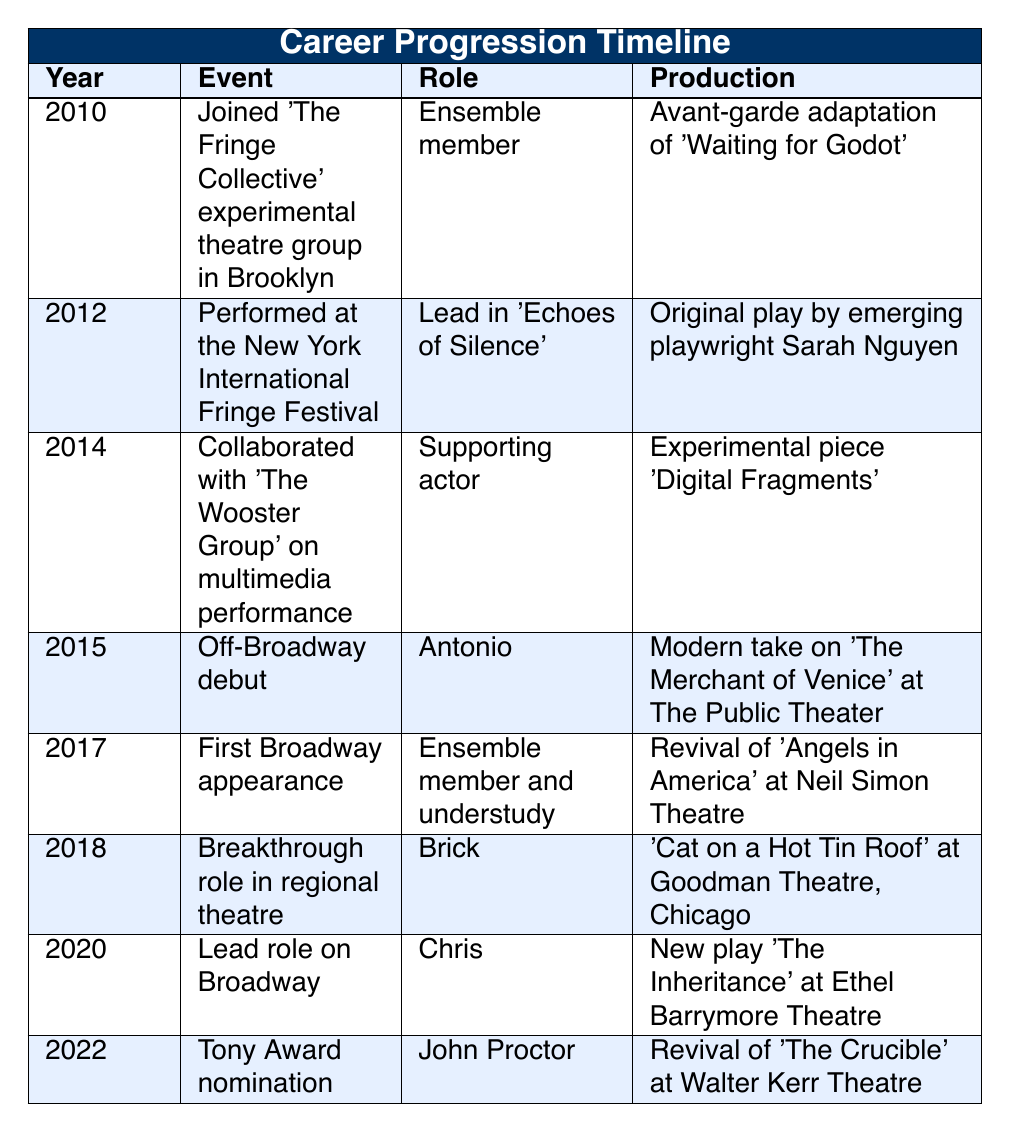What year did the actor join 'The Fringe Collective'? According to the table, the actor joined 'The Fringe Collective' in the year 2010.
Answer: 2010 What was the role played in the 2015 Off-Broadway debut? In the 2015 Off-Broadway debut, the actor played the role of Antonio in a modern adaptation of 'The Merchant of Venice' at The Public Theater.
Answer: Antonio How many years passed between the actor's first Broadway appearance and their Tony Award nomination? The first Broadway appearance took place in 2017, and the Tony Award nomination was in 2022. Therefore, the difference is 2022 - 2017 = 5 years.
Answer: 5 years Is the role of Chris in 'The Inheritance' a lead role or a supporting role? The table classifies Chris in 'The Inheritance' as a lead role on Broadway, which clearly indicates it is not a supporting role.
Answer: Yes In which year did the actor experience a breakthrough role in regional theatre? The table specifies the breakthrough role in regional theatre occurred in 2018 when the actor played Brick in 'Cat on a Hot Tin Roof' at Goodman Theatre, Chicago.
Answer: 2018 What productions did the actor participate in during 2014 and 2015? In 2014, the actor collaborated with 'The Wooster Group' on 'Digital Fragments' as a supporting actor. In 2015, they had their Off-Broadway debut in 'The Merchant of Venice' as Antonio.
Answer: 'Digital Fragments' and 'The Merchant of Venice' Which event was performed at the New York International Fringe Festival? The event at the New York International Fringe Festival was 'Echoes of Silence,' where the actor played the lead role in 2012.
Answer: 'Echoes of Silence' How does the number of years between joining the experimental theatre and the breakthrough role compare to the time from breakthrough role to a lead role on Broadway? The actor joined the experimental theatre in 2010 and had a breakthrough role in 2018, giving 8 years (2018 - 2010 = 8). The lead role on Broadway was in 2020, which is 2 years from the breakthrough role (2020 - 2018 = 2). Thus, the time from joining to breakthrough is longer than from breakthrough to lead role.
Answer: Longer What was the earliest event listed in the timeline? The earliest event listed in the timeline is joining 'The Fringe Collective' in 2010.
Answer: Joining 'The Fringe Collective' in 2010 